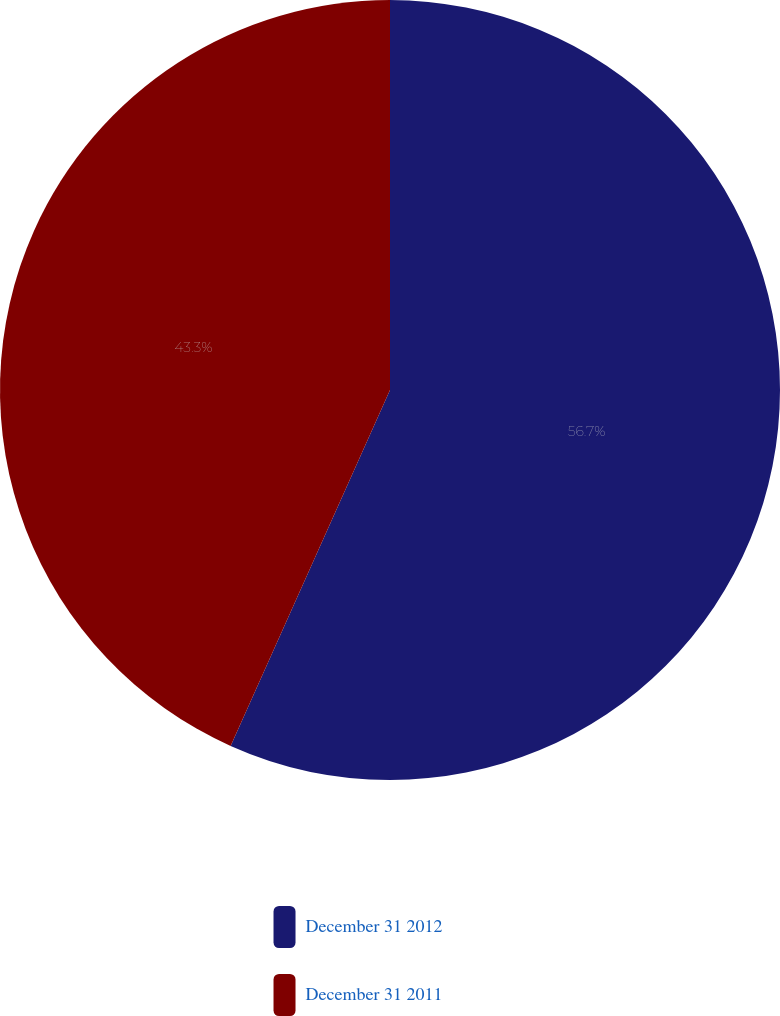Convert chart. <chart><loc_0><loc_0><loc_500><loc_500><pie_chart><fcel>December 31 2012<fcel>December 31 2011<nl><fcel>56.7%<fcel>43.3%<nl></chart> 